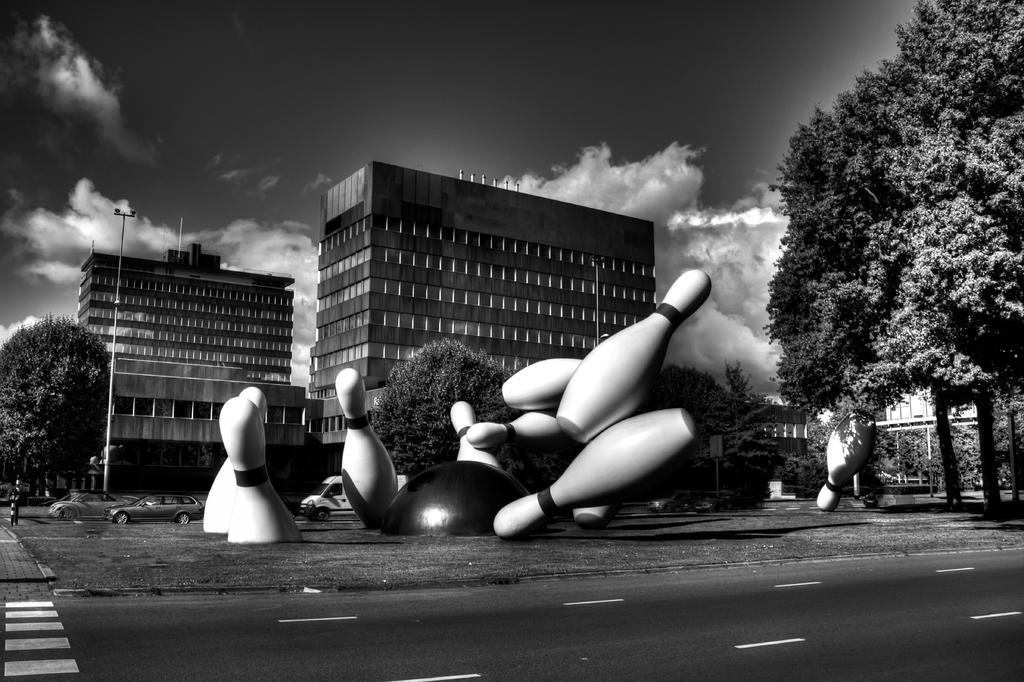Please provide a concise description of this image. In this picture we can observe large bowling pins. There is a road. We can observe trees and a pole. In the background there are buildings and a sky with some clouds. 